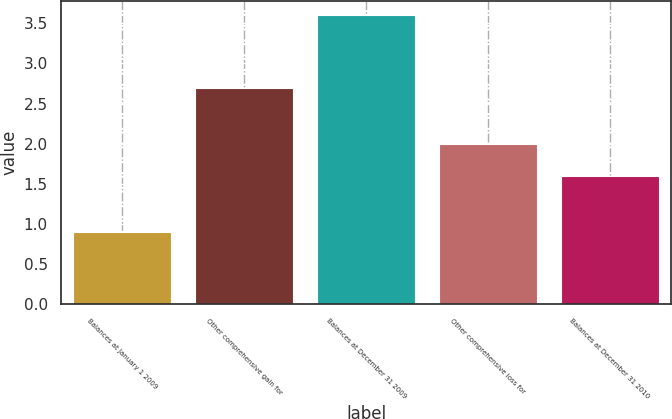Convert chart. <chart><loc_0><loc_0><loc_500><loc_500><bar_chart><fcel>Balances at January 1 2009<fcel>Other comprehensive gain for<fcel>Balances at December 31 2009<fcel>Other comprehensive loss for<fcel>Balances at December 31 2010<nl><fcel>0.9<fcel>2.7<fcel>3.6<fcel>2<fcel>1.6<nl></chart> 